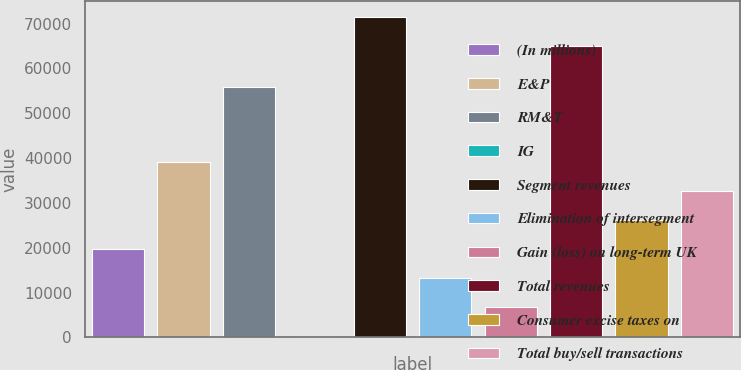<chart> <loc_0><loc_0><loc_500><loc_500><bar_chart><fcel>(In millions)<fcel>E&P<fcel>RM&T<fcel>IG<fcel>Segment revenues<fcel>Elimination of intersegment<fcel>Gain (loss) on long-term UK<fcel>Total revenues<fcel>Consumer excise taxes on<fcel>Total buy/sell transactions<nl><fcel>19664.3<fcel>39149.6<fcel>55941<fcel>179<fcel>71391.1<fcel>13169.2<fcel>6674.1<fcel>64896<fcel>26159.4<fcel>32654.5<nl></chart> 